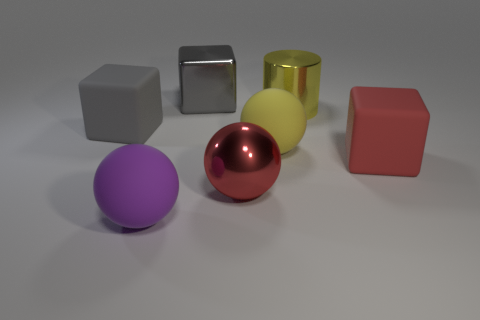The red object that is to the left of the big yellow metal object has what shape?
Provide a short and direct response. Sphere. How many purple objects are large shiny blocks or large shiny objects?
Make the answer very short. 0. Do the big cylinder and the yellow sphere have the same material?
Your response must be concise. No. There is a red metallic ball; what number of large matte objects are on the right side of it?
Offer a terse response. 2. What is the cube that is both right of the large purple matte object and on the left side of the big cylinder made of?
Your answer should be very brief. Metal. What number of balls are either big yellow things or gray things?
Offer a very short reply. 1. There is a big red object that is the same shape as the big purple thing; what is its material?
Provide a short and direct response. Metal. There is a yellow thing that is made of the same material as the red ball; what size is it?
Keep it short and to the point. Large. Do the matte thing that is in front of the big metal ball and the yellow object that is on the left side of the yellow metal cylinder have the same shape?
Provide a short and direct response. Yes. What color is the other ball that is made of the same material as the large yellow sphere?
Make the answer very short. Purple. 